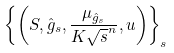<formula> <loc_0><loc_0><loc_500><loc_500>\left \{ \left ( S , \hat { g } _ { s } , \frac { \mu _ { \hat { g } _ { s } } } { K \sqrt { s } ^ { n } } , u \right ) \right \} _ { s }</formula> 